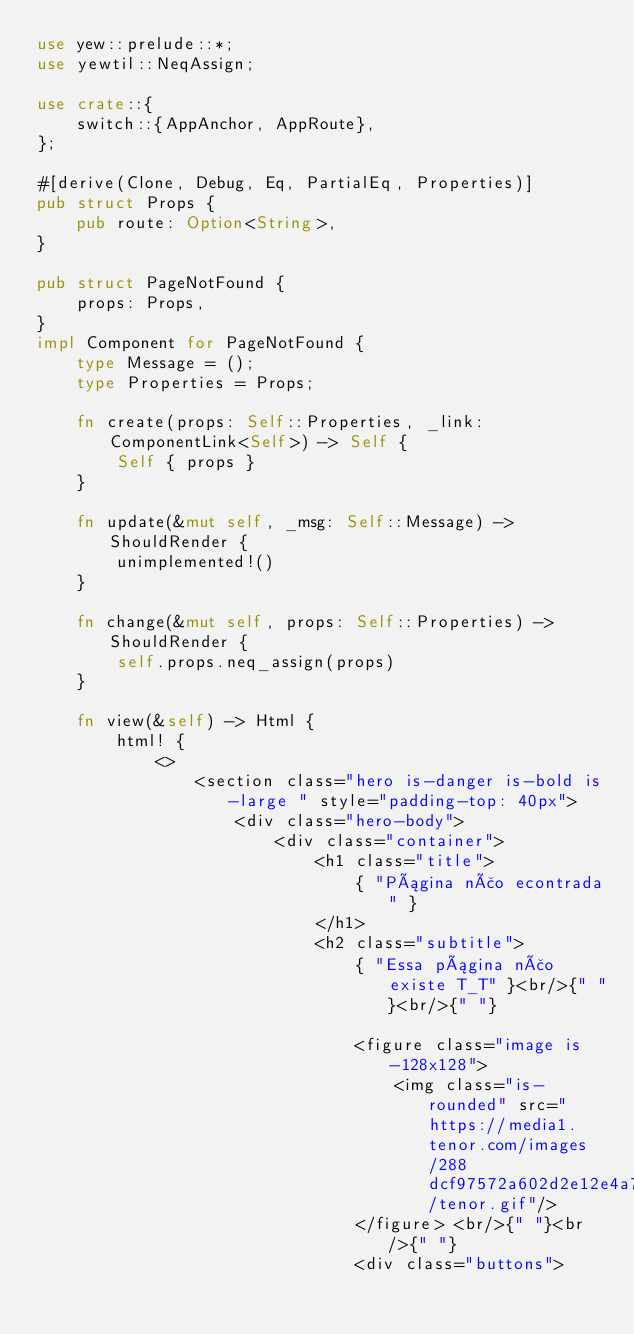<code> <loc_0><loc_0><loc_500><loc_500><_Rust_>use yew::prelude::*;
use yewtil::NeqAssign;

use crate::{
    switch::{AppAnchor, AppRoute},
};

#[derive(Clone, Debug, Eq, PartialEq, Properties)]
pub struct Props {
    pub route: Option<String>,
}

pub struct PageNotFound {
    props: Props,
}
impl Component for PageNotFound {
    type Message = ();
    type Properties = Props;

    fn create(props: Self::Properties, _link: ComponentLink<Self>) -> Self {
        Self { props }
    }

    fn update(&mut self, _msg: Self::Message) -> ShouldRender {
        unimplemented!()
    }

    fn change(&mut self, props: Self::Properties) -> ShouldRender {
        self.props.neq_assign(props)
    }

    fn view(&self) -> Html {
        html! {
            <>
                <section class="hero is-danger is-bold is-large " style="padding-top: 40px">
                    <div class="hero-body">
                        <div class="container">
                            <h1 class="title">
                                { "Página não econtrada" }
                            </h1>
                            <h2 class="subtitle">
                                { "Essa página não existe T_T" }<br/>{" "}<br/>{" "}
                                
                                <figure class="image is-128x128">
                                    <img class="is-rounded" src="https://media1.tenor.com/images/288dcf97572a602d2e12e4a7b7f0fc6b/tenor.gif"/>
                                </figure> <br/>{" "}<br/>{" "}
                                <div class="buttons"></code> 